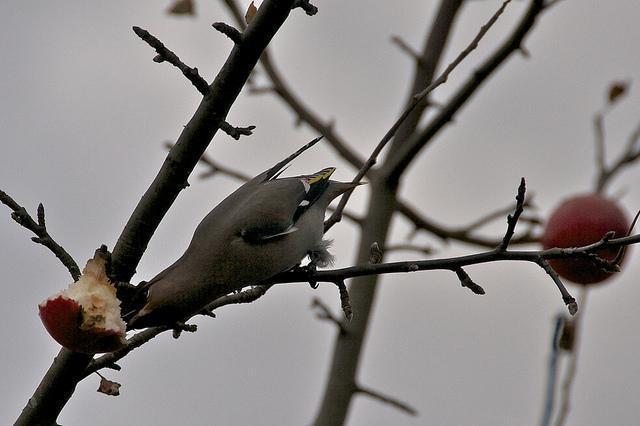How many birds are pictured?
Give a very brief answer. 1. How many apples can be seen?
Give a very brief answer. 2. How many people are behind the glass?
Give a very brief answer. 0. 